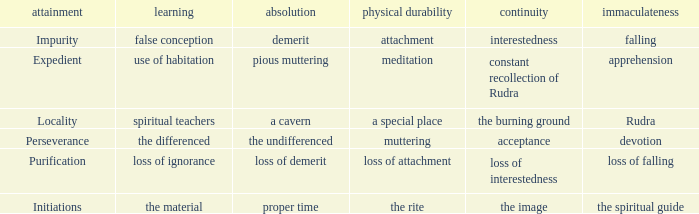 what's the constancy where permanence of the body is meditation Constant recollection of rudra. 